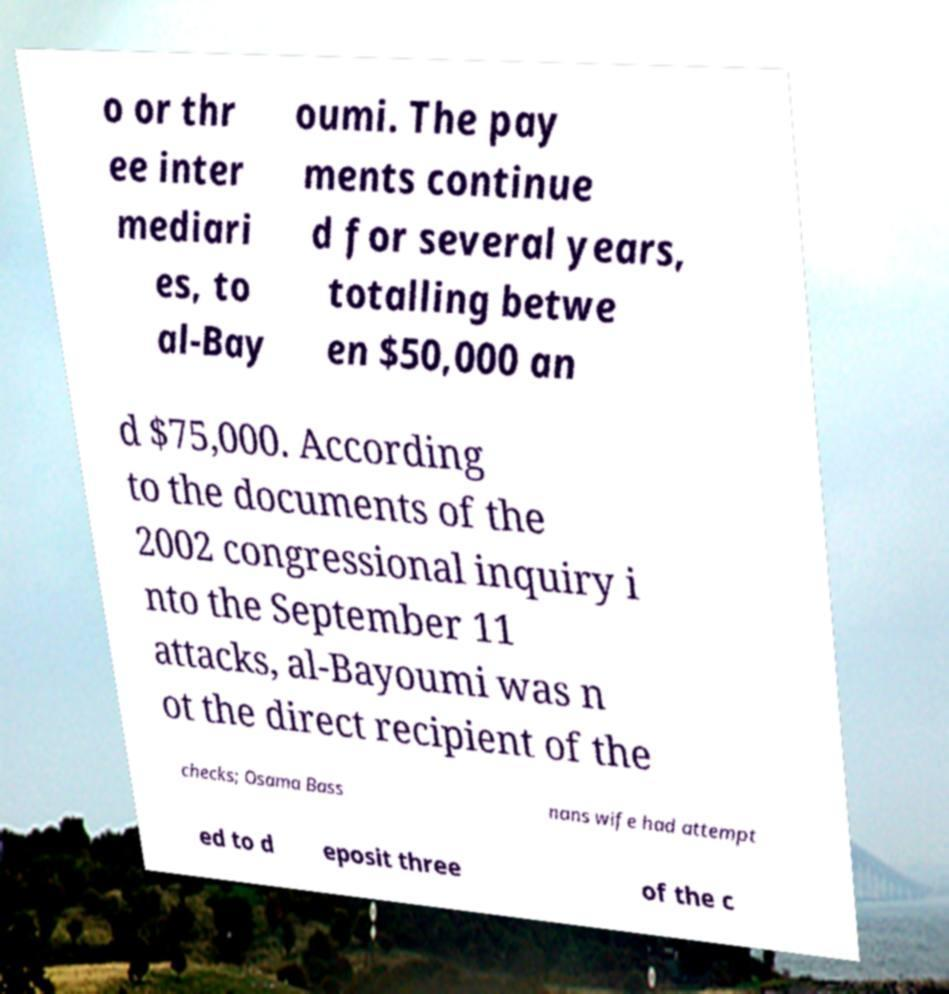Please read and relay the text visible in this image. What does it say? o or thr ee inter mediari es, to al-Bay oumi. The pay ments continue d for several years, totalling betwe en $50,000 an d $75,000. According to the documents of the 2002 congressional inquiry i nto the September 11 attacks, al-Bayoumi was n ot the direct recipient of the checks; Osama Bass nans wife had attempt ed to d eposit three of the c 